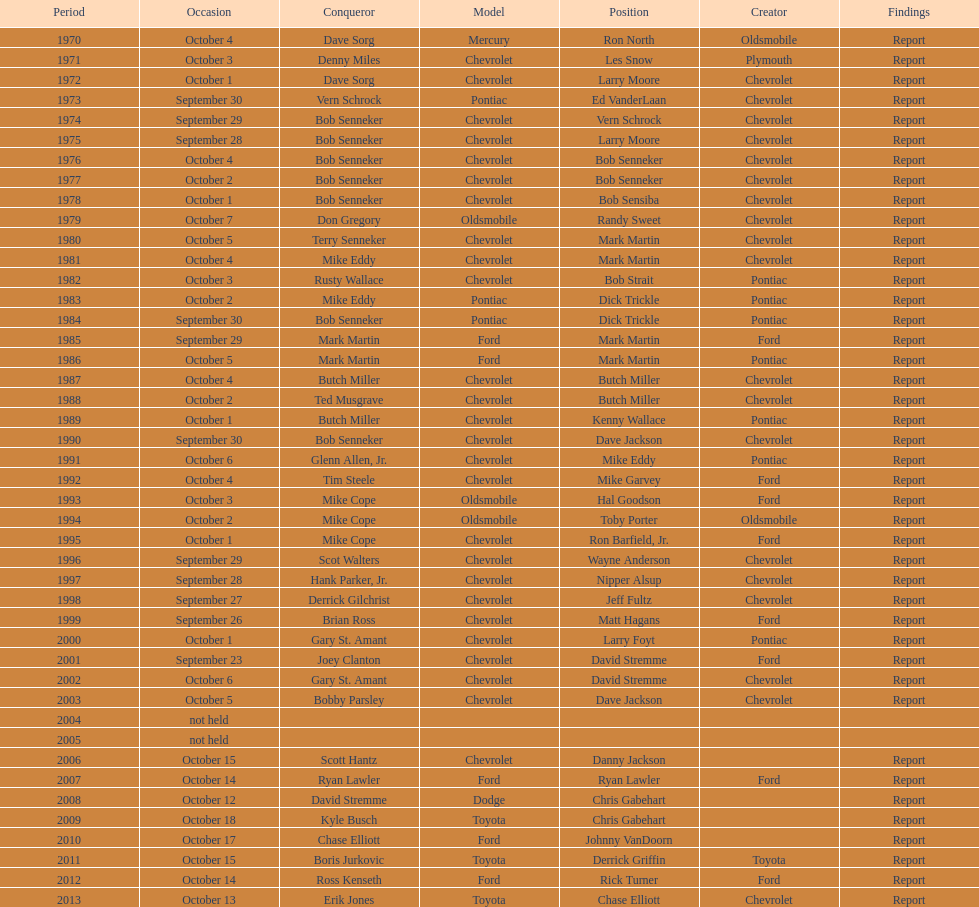How many winning oldsmobile vehicles made the list? 3. 